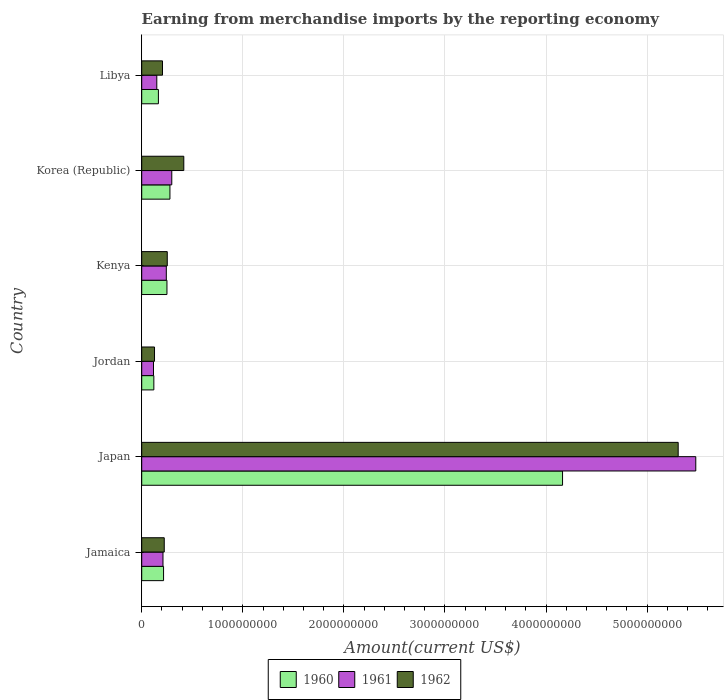How many different coloured bars are there?
Your answer should be compact. 3. How many groups of bars are there?
Your answer should be very brief. 6. Are the number of bars per tick equal to the number of legend labels?
Provide a short and direct response. Yes. What is the label of the 1st group of bars from the top?
Offer a terse response. Libya. In how many cases, is the number of bars for a given country not equal to the number of legend labels?
Offer a terse response. 0. What is the amount earned from merchandise imports in 1960 in Korea (Republic)?
Keep it short and to the point. 2.79e+08. Across all countries, what is the maximum amount earned from merchandise imports in 1960?
Provide a succinct answer. 4.16e+09. Across all countries, what is the minimum amount earned from merchandise imports in 1962?
Your answer should be compact. 1.27e+08. In which country was the amount earned from merchandise imports in 1961 minimum?
Your answer should be very brief. Jordan. What is the total amount earned from merchandise imports in 1960 in the graph?
Your response must be concise. 5.19e+09. What is the difference between the amount earned from merchandise imports in 1962 in Jamaica and that in Korea (Republic)?
Your answer should be very brief. -1.93e+08. What is the difference between the amount earned from merchandise imports in 1962 in Kenya and the amount earned from merchandise imports in 1961 in Libya?
Your answer should be compact. 1.04e+08. What is the average amount earned from merchandise imports in 1962 per country?
Offer a very short reply. 1.09e+09. What is the difference between the amount earned from merchandise imports in 1961 and amount earned from merchandise imports in 1960 in Korea (Republic)?
Provide a succinct answer. 1.82e+07. What is the ratio of the amount earned from merchandise imports in 1962 in Kenya to that in Korea (Republic)?
Offer a very short reply. 0.61. Is the amount earned from merchandise imports in 1961 in Jamaica less than that in Libya?
Your answer should be compact. No. What is the difference between the highest and the second highest amount earned from merchandise imports in 1961?
Offer a very short reply. 5.18e+09. What is the difference between the highest and the lowest amount earned from merchandise imports in 1962?
Ensure brevity in your answer.  5.18e+09. In how many countries, is the amount earned from merchandise imports in 1961 greater than the average amount earned from merchandise imports in 1961 taken over all countries?
Provide a succinct answer. 1. What does the 3rd bar from the top in Kenya represents?
Your answer should be very brief. 1960. What does the 2nd bar from the bottom in Libya represents?
Keep it short and to the point. 1961. Is it the case that in every country, the sum of the amount earned from merchandise imports in 1961 and amount earned from merchandise imports in 1960 is greater than the amount earned from merchandise imports in 1962?
Make the answer very short. Yes. Are all the bars in the graph horizontal?
Your answer should be compact. Yes. How many countries are there in the graph?
Offer a terse response. 6. Does the graph contain grids?
Ensure brevity in your answer.  Yes. How many legend labels are there?
Your answer should be compact. 3. How are the legend labels stacked?
Offer a terse response. Horizontal. What is the title of the graph?
Ensure brevity in your answer.  Earning from merchandise imports by the reporting economy. Does "1963" appear as one of the legend labels in the graph?
Keep it short and to the point. No. What is the label or title of the X-axis?
Provide a succinct answer. Amount(current US$). What is the label or title of the Y-axis?
Keep it short and to the point. Country. What is the Amount(current US$) in 1960 in Jamaica?
Offer a terse response. 2.16e+08. What is the Amount(current US$) in 1961 in Jamaica?
Offer a terse response. 2.10e+08. What is the Amount(current US$) of 1962 in Jamaica?
Offer a very short reply. 2.23e+08. What is the Amount(current US$) in 1960 in Japan?
Provide a short and direct response. 4.16e+09. What is the Amount(current US$) in 1961 in Japan?
Your answer should be compact. 5.48e+09. What is the Amount(current US$) in 1962 in Japan?
Your answer should be compact. 5.31e+09. What is the Amount(current US$) of 1960 in Jordan?
Offer a very short reply. 1.20e+08. What is the Amount(current US$) of 1961 in Jordan?
Give a very brief answer. 1.16e+08. What is the Amount(current US$) of 1962 in Jordan?
Your answer should be very brief. 1.27e+08. What is the Amount(current US$) of 1960 in Kenya?
Give a very brief answer. 2.50e+08. What is the Amount(current US$) in 1961 in Kenya?
Your answer should be very brief. 2.43e+08. What is the Amount(current US$) in 1962 in Kenya?
Provide a succinct answer. 2.53e+08. What is the Amount(current US$) of 1960 in Korea (Republic)?
Provide a short and direct response. 2.79e+08. What is the Amount(current US$) of 1961 in Korea (Republic)?
Offer a terse response. 2.97e+08. What is the Amount(current US$) of 1962 in Korea (Republic)?
Keep it short and to the point. 4.16e+08. What is the Amount(current US$) in 1960 in Libya?
Keep it short and to the point. 1.65e+08. What is the Amount(current US$) in 1961 in Libya?
Your answer should be compact. 1.49e+08. What is the Amount(current US$) of 1962 in Libya?
Offer a very short reply. 2.06e+08. Across all countries, what is the maximum Amount(current US$) of 1960?
Provide a succinct answer. 4.16e+09. Across all countries, what is the maximum Amount(current US$) in 1961?
Offer a very short reply. 5.48e+09. Across all countries, what is the maximum Amount(current US$) in 1962?
Your answer should be compact. 5.31e+09. Across all countries, what is the minimum Amount(current US$) in 1960?
Provide a succinct answer. 1.20e+08. Across all countries, what is the minimum Amount(current US$) in 1961?
Your answer should be compact. 1.16e+08. Across all countries, what is the minimum Amount(current US$) in 1962?
Give a very brief answer. 1.27e+08. What is the total Amount(current US$) of 1960 in the graph?
Your answer should be very brief. 5.19e+09. What is the total Amount(current US$) in 1961 in the graph?
Give a very brief answer. 6.50e+09. What is the total Amount(current US$) in 1962 in the graph?
Keep it short and to the point. 6.53e+09. What is the difference between the Amount(current US$) of 1960 in Jamaica and that in Japan?
Provide a succinct answer. -3.95e+09. What is the difference between the Amount(current US$) of 1961 in Jamaica and that in Japan?
Your answer should be very brief. -5.27e+09. What is the difference between the Amount(current US$) in 1962 in Jamaica and that in Japan?
Your answer should be very brief. -5.08e+09. What is the difference between the Amount(current US$) of 1960 in Jamaica and that in Jordan?
Provide a short and direct response. 9.62e+07. What is the difference between the Amount(current US$) in 1961 in Jamaica and that in Jordan?
Your response must be concise. 9.39e+07. What is the difference between the Amount(current US$) in 1962 in Jamaica and that in Jordan?
Offer a terse response. 9.63e+07. What is the difference between the Amount(current US$) of 1960 in Jamaica and that in Kenya?
Your answer should be compact. -3.35e+07. What is the difference between the Amount(current US$) of 1961 in Jamaica and that in Kenya?
Ensure brevity in your answer.  -3.29e+07. What is the difference between the Amount(current US$) in 1962 in Jamaica and that in Kenya?
Provide a succinct answer. -2.98e+07. What is the difference between the Amount(current US$) of 1960 in Jamaica and that in Korea (Republic)?
Your answer should be compact. -6.31e+07. What is the difference between the Amount(current US$) in 1961 in Jamaica and that in Korea (Republic)?
Your answer should be compact. -8.70e+07. What is the difference between the Amount(current US$) in 1962 in Jamaica and that in Korea (Republic)?
Provide a succinct answer. -1.93e+08. What is the difference between the Amount(current US$) of 1960 in Jamaica and that in Libya?
Offer a very short reply. 5.11e+07. What is the difference between the Amount(current US$) of 1961 in Jamaica and that in Libya?
Ensure brevity in your answer.  6.12e+07. What is the difference between the Amount(current US$) in 1962 in Jamaica and that in Libya?
Offer a terse response. 1.73e+07. What is the difference between the Amount(current US$) of 1960 in Japan and that in Jordan?
Give a very brief answer. 4.04e+09. What is the difference between the Amount(current US$) of 1961 in Japan and that in Jordan?
Give a very brief answer. 5.36e+09. What is the difference between the Amount(current US$) of 1962 in Japan and that in Jordan?
Ensure brevity in your answer.  5.18e+09. What is the difference between the Amount(current US$) in 1960 in Japan and that in Kenya?
Provide a short and direct response. 3.91e+09. What is the difference between the Amount(current US$) in 1961 in Japan and that in Kenya?
Offer a very short reply. 5.24e+09. What is the difference between the Amount(current US$) of 1962 in Japan and that in Kenya?
Make the answer very short. 5.05e+09. What is the difference between the Amount(current US$) of 1960 in Japan and that in Korea (Republic)?
Offer a very short reply. 3.88e+09. What is the difference between the Amount(current US$) in 1961 in Japan and that in Korea (Republic)?
Offer a very short reply. 5.18e+09. What is the difference between the Amount(current US$) of 1962 in Japan and that in Korea (Republic)?
Your answer should be compact. 4.89e+09. What is the difference between the Amount(current US$) of 1960 in Japan and that in Libya?
Give a very brief answer. 4.00e+09. What is the difference between the Amount(current US$) of 1961 in Japan and that in Libya?
Your answer should be very brief. 5.33e+09. What is the difference between the Amount(current US$) in 1962 in Japan and that in Libya?
Make the answer very short. 5.10e+09. What is the difference between the Amount(current US$) of 1960 in Jordan and that in Kenya?
Provide a succinct answer. -1.30e+08. What is the difference between the Amount(current US$) of 1961 in Jordan and that in Kenya?
Offer a very short reply. -1.27e+08. What is the difference between the Amount(current US$) in 1962 in Jordan and that in Kenya?
Offer a terse response. -1.26e+08. What is the difference between the Amount(current US$) of 1960 in Jordan and that in Korea (Republic)?
Give a very brief answer. -1.59e+08. What is the difference between the Amount(current US$) in 1961 in Jordan and that in Korea (Republic)?
Offer a very short reply. -1.81e+08. What is the difference between the Amount(current US$) of 1962 in Jordan and that in Korea (Republic)?
Ensure brevity in your answer.  -2.90e+08. What is the difference between the Amount(current US$) of 1960 in Jordan and that in Libya?
Provide a succinct answer. -4.51e+07. What is the difference between the Amount(current US$) in 1961 in Jordan and that in Libya?
Give a very brief answer. -3.27e+07. What is the difference between the Amount(current US$) of 1962 in Jordan and that in Libya?
Give a very brief answer. -7.90e+07. What is the difference between the Amount(current US$) in 1960 in Kenya and that in Korea (Republic)?
Your response must be concise. -2.96e+07. What is the difference between the Amount(current US$) of 1961 in Kenya and that in Korea (Republic)?
Offer a very short reply. -5.41e+07. What is the difference between the Amount(current US$) in 1962 in Kenya and that in Korea (Republic)?
Offer a very short reply. -1.64e+08. What is the difference between the Amount(current US$) of 1960 in Kenya and that in Libya?
Your response must be concise. 8.46e+07. What is the difference between the Amount(current US$) in 1961 in Kenya and that in Libya?
Your response must be concise. 9.41e+07. What is the difference between the Amount(current US$) of 1962 in Kenya and that in Libya?
Offer a very short reply. 4.71e+07. What is the difference between the Amount(current US$) in 1960 in Korea (Republic) and that in Libya?
Ensure brevity in your answer.  1.14e+08. What is the difference between the Amount(current US$) in 1961 in Korea (Republic) and that in Libya?
Ensure brevity in your answer.  1.48e+08. What is the difference between the Amount(current US$) of 1962 in Korea (Republic) and that in Libya?
Make the answer very short. 2.11e+08. What is the difference between the Amount(current US$) of 1960 in Jamaica and the Amount(current US$) of 1961 in Japan?
Provide a succinct answer. -5.27e+09. What is the difference between the Amount(current US$) of 1960 in Jamaica and the Amount(current US$) of 1962 in Japan?
Keep it short and to the point. -5.09e+09. What is the difference between the Amount(current US$) in 1961 in Jamaica and the Amount(current US$) in 1962 in Japan?
Ensure brevity in your answer.  -5.10e+09. What is the difference between the Amount(current US$) in 1960 in Jamaica and the Amount(current US$) in 1961 in Jordan?
Give a very brief answer. 9.96e+07. What is the difference between the Amount(current US$) in 1960 in Jamaica and the Amount(current US$) in 1962 in Jordan?
Your answer should be compact. 8.95e+07. What is the difference between the Amount(current US$) of 1961 in Jamaica and the Amount(current US$) of 1962 in Jordan?
Make the answer very short. 8.38e+07. What is the difference between the Amount(current US$) in 1960 in Jamaica and the Amount(current US$) in 1961 in Kenya?
Your answer should be compact. -2.72e+07. What is the difference between the Amount(current US$) in 1960 in Jamaica and the Amount(current US$) in 1962 in Kenya?
Ensure brevity in your answer.  -3.66e+07. What is the difference between the Amount(current US$) of 1961 in Jamaica and the Amount(current US$) of 1962 in Kenya?
Your answer should be very brief. -4.23e+07. What is the difference between the Amount(current US$) in 1960 in Jamaica and the Amount(current US$) in 1961 in Korea (Republic)?
Provide a short and direct response. -8.13e+07. What is the difference between the Amount(current US$) in 1960 in Jamaica and the Amount(current US$) in 1962 in Korea (Republic)?
Provide a succinct answer. -2.00e+08. What is the difference between the Amount(current US$) in 1961 in Jamaica and the Amount(current US$) in 1962 in Korea (Republic)?
Offer a very short reply. -2.06e+08. What is the difference between the Amount(current US$) of 1960 in Jamaica and the Amount(current US$) of 1961 in Libya?
Offer a very short reply. 6.69e+07. What is the difference between the Amount(current US$) of 1960 in Jamaica and the Amount(current US$) of 1962 in Libya?
Offer a terse response. 1.05e+07. What is the difference between the Amount(current US$) of 1961 in Jamaica and the Amount(current US$) of 1962 in Libya?
Your answer should be compact. 4.80e+06. What is the difference between the Amount(current US$) of 1960 in Japan and the Amount(current US$) of 1961 in Jordan?
Provide a short and direct response. 4.05e+09. What is the difference between the Amount(current US$) of 1960 in Japan and the Amount(current US$) of 1962 in Jordan?
Your answer should be compact. 4.04e+09. What is the difference between the Amount(current US$) in 1961 in Japan and the Amount(current US$) in 1962 in Jordan?
Offer a very short reply. 5.35e+09. What is the difference between the Amount(current US$) of 1960 in Japan and the Amount(current US$) of 1961 in Kenya?
Ensure brevity in your answer.  3.92e+09. What is the difference between the Amount(current US$) in 1960 in Japan and the Amount(current US$) in 1962 in Kenya?
Your answer should be very brief. 3.91e+09. What is the difference between the Amount(current US$) in 1961 in Japan and the Amount(current US$) in 1962 in Kenya?
Offer a very short reply. 5.23e+09. What is the difference between the Amount(current US$) of 1960 in Japan and the Amount(current US$) of 1961 in Korea (Republic)?
Your answer should be very brief. 3.87e+09. What is the difference between the Amount(current US$) of 1960 in Japan and the Amount(current US$) of 1962 in Korea (Republic)?
Provide a short and direct response. 3.75e+09. What is the difference between the Amount(current US$) of 1961 in Japan and the Amount(current US$) of 1962 in Korea (Republic)?
Provide a succinct answer. 5.07e+09. What is the difference between the Amount(current US$) in 1960 in Japan and the Amount(current US$) in 1961 in Libya?
Ensure brevity in your answer.  4.01e+09. What is the difference between the Amount(current US$) in 1960 in Japan and the Amount(current US$) in 1962 in Libya?
Keep it short and to the point. 3.96e+09. What is the difference between the Amount(current US$) in 1961 in Japan and the Amount(current US$) in 1962 in Libya?
Provide a short and direct response. 5.28e+09. What is the difference between the Amount(current US$) in 1960 in Jordan and the Amount(current US$) in 1961 in Kenya?
Offer a very short reply. -1.23e+08. What is the difference between the Amount(current US$) in 1960 in Jordan and the Amount(current US$) in 1962 in Kenya?
Your response must be concise. -1.33e+08. What is the difference between the Amount(current US$) of 1961 in Jordan and the Amount(current US$) of 1962 in Kenya?
Offer a very short reply. -1.36e+08. What is the difference between the Amount(current US$) of 1960 in Jordan and the Amount(current US$) of 1961 in Korea (Republic)?
Your answer should be compact. -1.78e+08. What is the difference between the Amount(current US$) in 1960 in Jordan and the Amount(current US$) in 1962 in Korea (Republic)?
Offer a very short reply. -2.96e+08. What is the difference between the Amount(current US$) of 1961 in Jordan and the Amount(current US$) of 1962 in Korea (Republic)?
Keep it short and to the point. -3.00e+08. What is the difference between the Amount(current US$) in 1960 in Jordan and the Amount(current US$) in 1961 in Libya?
Provide a succinct answer. -2.93e+07. What is the difference between the Amount(current US$) of 1960 in Jordan and the Amount(current US$) of 1962 in Libya?
Give a very brief answer. -8.57e+07. What is the difference between the Amount(current US$) in 1961 in Jordan and the Amount(current US$) in 1962 in Libya?
Provide a succinct answer. -8.91e+07. What is the difference between the Amount(current US$) of 1960 in Kenya and the Amount(current US$) of 1961 in Korea (Republic)?
Offer a terse response. -4.78e+07. What is the difference between the Amount(current US$) in 1960 in Kenya and the Amount(current US$) in 1962 in Korea (Republic)?
Keep it short and to the point. -1.67e+08. What is the difference between the Amount(current US$) of 1961 in Kenya and the Amount(current US$) of 1962 in Korea (Republic)?
Offer a terse response. -1.73e+08. What is the difference between the Amount(current US$) of 1960 in Kenya and the Amount(current US$) of 1961 in Libya?
Your answer should be very brief. 1.00e+08. What is the difference between the Amount(current US$) of 1960 in Kenya and the Amount(current US$) of 1962 in Libya?
Provide a succinct answer. 4.40e+07. What is the difference between the Amount(current US$) in 1961 in Kenya and the Amount(current US$) in 1962 in Libya?
Ensure brevity in your answer.  3.77e+07. What is the difference between the Amount(current US$) in 1960 in Korea (Republic) and the Amount(current US$) in 1961 in Libya?
Your response must be concise. 1.30e+08. What is the difference between the Amount(current US$) of 1960 in Korea (Republic) and the Amount(current US$) of 1962 in Libya?
Keep it short and to the point. 7.36e+07. What is the difference between the Amount(current US$) of 1961 in Korea (Republic) and the Amount(current US$) of 1962 in Libya?
Your answer should be compact. 9.18e+07. What is the average Amount(current US$) in 1960 per country?
Your answer should be very brief. 8.66e+08. What is the average Amount(current US$) of 1961 per country?
Give a very brief answer. 1.08e+09. What is the average Amount(current US$) in 1962 per country?
Your response must be concise. 1.09e+09. What is the difference between the Amount(current US$) of 1960 and Amount(current US$) of 1961 in Jamaica?
Provide a succinct answer. 5.70e+06. What is the difference between the Amount(current US$) in 1960 and Amount(current US$) in 1962 in Jamaica?
Offer a very short reply. -6.80e+06. What is the difference between the Amount(current US$) in 1961 and Amount(current US$) in 1962 in Jamaica?
Your answer should be compact. -1.25e+07. What is the difference between the Amount(current US$) of 1960 and Amount(current US$) of 1961 in Japan?
Keep it short and to the point. -1.32e+09. What is the difference between the Amount(current US$) in 1960 and Amount(current US$) in 1962 in Japan?
Your answer should be very brief. -1.14e+09. What is the difference between the Amount(current US$) in 1961 and Amount(current US$) in 1962 in Japan?
Offer a terse response. 1.74e+08. What is the difference between the Amount(current US$) in 1960 and Amount(current US$) in 1961 in Jordan?
Your response must be concise. 3.40e+06. What is the difference between the Amount(current US$) of 1960 and Amount(current US$) of 1962 in Jordan?
Your response must be concise. -6.70e+06. What is the difference between the Amount(current US$) of 1961 and Amount(current US$) of 1962 in Jordan?
Offer a very short reply. -1.01e+07. What is the difference between the Amount(current US$) in 1960 and Amount(current US$) in 1961 in Kenya?
Your response must be concise. 6.30e+06. What is the difference between the Amount(current US$) in 1960 and Amount(current US$) in 1962 in Kenya?
Keep it short and to the point. -3.10e+06. What is the difference between the Amount(current US$) of 1961 and Amount(current US$) of 1962 in Kenya?
Offer a very short reply. -9.40e+06. What is the difference between the Amount(current US$) in 1960 and Amount(current US$) in 1961 in Korea (Republic)?
Make the answer very short. -1.82e+07. What is the difference between the Amount(current US$) in 1960 and Amount(current US$) in 1962 in Korea (Republic)?
Your response must be concise. -1.37e+08. What is the difference between the Amount(current US$) in 1961 and Amount(current US$) in 1962 in Korea (Republic)?
Keep it short and to the point. -1.19e+08. What is the difference between the Amount(current US$) of 1960 and Amount(current US$) of 1961 in Libya?
Offer a very short reply. 1.58e+07. What is the difference between the Amount(current US$) of 1960 and Amount(current US$) of 1962 in Libya?
Provide a succinct answer. -4.06e+07. What is the difference between the Amount(current US$) in 1961 and Amount(current US$) in 1962 in Libya?
Your answer should be very brief. -5.64e+07. What is the ratio of the Amount(current US$) of 1960 in Jamaica to that in Japan?
Give a very brief answer. 0.05. What is the ratio of the Amount(current US$) of 1961 in Jamaica to that in Japan?
Make the answer very short. 0.04. What is the ratio of the Amount(current US$) of 1962 in Jamaica to that in Japan?
Ensure brevity in your answer.  0.04. What is the ratio of the Amount(current US$) of 1960 in Jamaica to that in Jordan?
Make the answer very short. 1.8. What is the ratio of the Amount(current US$) in 1961 in Jamaica to that in Jordan?
Offer a very short reply. 1.81. What is the ratio of the Amount(current US$) of 1962 in Jamaica to that in Jordan?
Offer a terse response. 1.76. What is the ratio of the Amount(current US$) of 1960 in Jamaica to that in Kenya?
Provide a succinct answer. 0.87. What is the ratio of the Amount(current US$) in 1961 in Jamaica to that in Kenya?
Your answer should be compact. 0.86. What is the ratio of the Amount(current US$) in 1962 in Jamaica to that in Kenya?
Your answer should be compact. 0.88. What is the ratio of the Amount(current US$) of 1960 in Jamaica to that in Korea (Republic)?
Your answer should be compact. 0.77. What is the ratio of the Amount(current US$) in 1961 in Jamaica to that in Korea (Republic)?
Offer a very short reply. 0.71. What is the ratio of the Amount(current US$) of 1962 in Jamaica to that in Korea (Republic)?
Provide a succinct answer. 0.54. What is the ratio of the Amount(current US$) in 1960 in Jamaica to that in Libya?
Your response must be concise. 1.31. What is the ratio of the Amount(current US$) of 1961 in Jamaica to that in Libya?
Keep it short and to the point. 1.41. What is the ratio of the Amount(current US$) in 1962 in Jamaica to that in Libya?
Offer a very short reply. 1.08. What is the ratio of the Amount(current US$) of 1960 in Japan to that in Jordan?
Ensure brevity in your answer.  34.72. What is the ratio of the Amount(current US$) in 1961 in Japan to that in Jordan?
Give a very brief answer. 47.05. What is the ratio of the Amount(current US$) of 1962 in Japan to that in Jordan?
Your answer should be very brief. 41.92. What is the ratio of the Amount(current US$) of 1960 in Japan to that in Kenya?
Offer a very short reply. 16.68. What is the ratio of the Amount(current US$) in 1961 in Japan to that in Kenya?
Your response must be concise. 22.53. What is the ratio of the Amount(current US$) of 1962 in Japan to that in Kenya?
Your response must be concise. 21. What is the ratio of the Amount(current US$) of 1960 in Japan to that in Korea (Republic)?
Provide a succinct answer. 14.91. What is the ratio of the Amount(current US$) of 1961 in Japan to that in Korea (Republic)?
Your answer should be very brief. 18.43. What is the ratio of the Amount(current US$) of 1962 in Japan to that in Korea (Republic)?
Offer a very short reply. 12.75. What is the ratio of the Amount(current US$) of 1960 in Japan to that in Libya?
Give a very brief answer. 25.23. What is the ratio of the Amount(current US$) in 1961 in Japan to that in Libya?
Provide a succinct answer. 36.74. What is the ratio of the Amount(current US$) of 1962 in Japan to that in Libya?
Offer a very short reply. 25.81. What is the ratio of the Amount(current US$) in 1960 in Jordan to that in Kenya?
Offer a very short reply. 0.48. What is the ratio of the Amount(current US$) in 1961 in Jordan to that in Kenya?
Offer a very short reply. 0.48. What is the ratio of the Amount(current US$) in 1962 in Jordan to that in Kenya?
Provide a succinct answer. 0.5. What is the ratio of the Amount(current US$) of 1960 in Jordan to that in Korea (Republic)?
Provide a succinct answer. 0.43. What is the ratio of the Amount(current US$) in 1961 in Jordan to that in Korea (Republic)?
Your answer should be compact. 0.39. What is the ratio of the Amount(current US$) in 1962 in Jordan to that in Korea (Republic)?
Offer a terse response. 0.3. What is the ratio of the Amount(current US$) in 1960 in Jordan to that in Libya?
Give a very brief answer. 0.73. What is the ratio of the Amount(current US$) of 1961 in Jordan to that in Libya?
Your answer should be very brief. 0.78. What is the ratio of the Amount(current US$) of 1962 in Jordan to that in Libya?
Provide a succinct answer. 0.62. What is the ratio of the Amount(current US$) in 1960 in Kenya to that in Korea (Republic)?
Your answer should be very brief. 0.89. What is the ratio of the Amount(current US$) in 1961 in Kenya to that in Korea (Republic)?
Offer a very short reply. 0.82. What is the ratio of the Amount(current US$) in 1962 in Kenya to that in Korea (Republic)?
Make the answer very short. 0.61. What is the ratio of the Amount(current US$) in 1960 in Kenya to that in Libya?
Provide a succinct answer. 1.51. What is the ratio of the Amount(current US$) in 1961 in Kenya to that in Libya?
Ensure brevity in your answer.  1.63. What is the ratio of the Amount(current US$) in 1962 in Kenya to that in Libya?
Your response must be concise. 1.23. What is the ratio of the Amount(current US$) in 1960 in Korea (Republic) to that in Libya?
Provide a short and direct response. 1.69. What is the ratio of the Amount(current US$) in 1961 in Korea (Republic) to that in Libya?
Ensure brevity in your answer.  1.99. What is the ratio of the Amount(current US$) in 1962 in Korea (Republic) to that in Libya?
Your answer should be compact. 2.02. What is the difference between the highest and the second highest Amount(current US$) of 1960?
Your answer should be compact. 3.88e+09. What is the difference between the highest and the second highest Amount(current US$) of 1961?
Ensure brevity in your answer.  5.18e+09. What is the difference between the highest and the second highest Amount(current US$) in 1962?
Keep it short and to the point. 4.89e+09. What is the difference between the highest and the lowest Amount(current US$) in 1960?
Your answer should be very brief. 4.04e+09. What is the difference between the highest and the lowest Amount(current US$) of 1961?
Your response must be concise. 5.36e+09. What is the difference between the highest and the lowest Amount(current US$) of 1962?
Offer a terse response. 5.18e+09. 